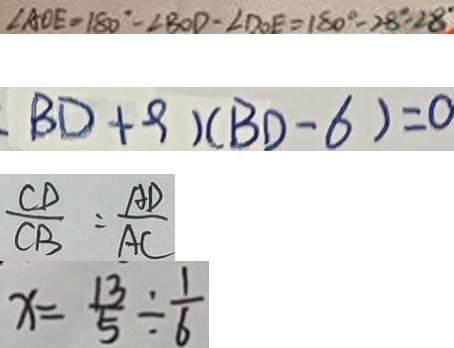<formula> <loc_0><loc_0><loc_500><loc_500>\angle A O E = 1 8 0 ^ { \circ } - \angle B O D - \angle D O E = 1 8 0 ^ { \circ } - 2 8 ^ { \circ } - 2 8 ^ { \circ } 
 B D + 9 ) ( B D - 6 ) = 0 
 \frac { C D } { C B } = \frac { A D } { A C } 
 x = \frac { 1 3 } { 5 } \div \frac { 1 } { 6 }</formula> 